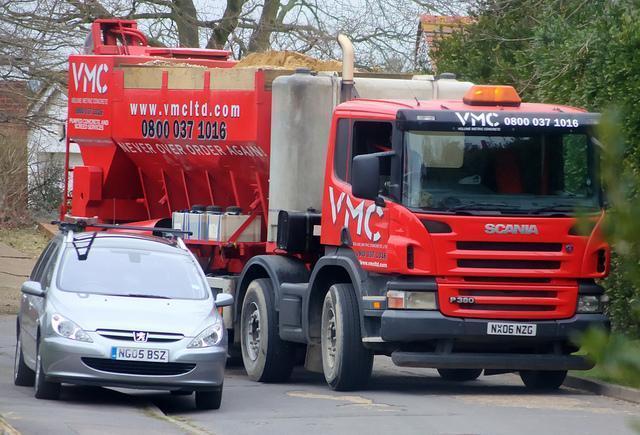How many people are in the truck?
Give a very brief answer. 0. How many orange cones do you see?
Give a very brief answer. 0. 